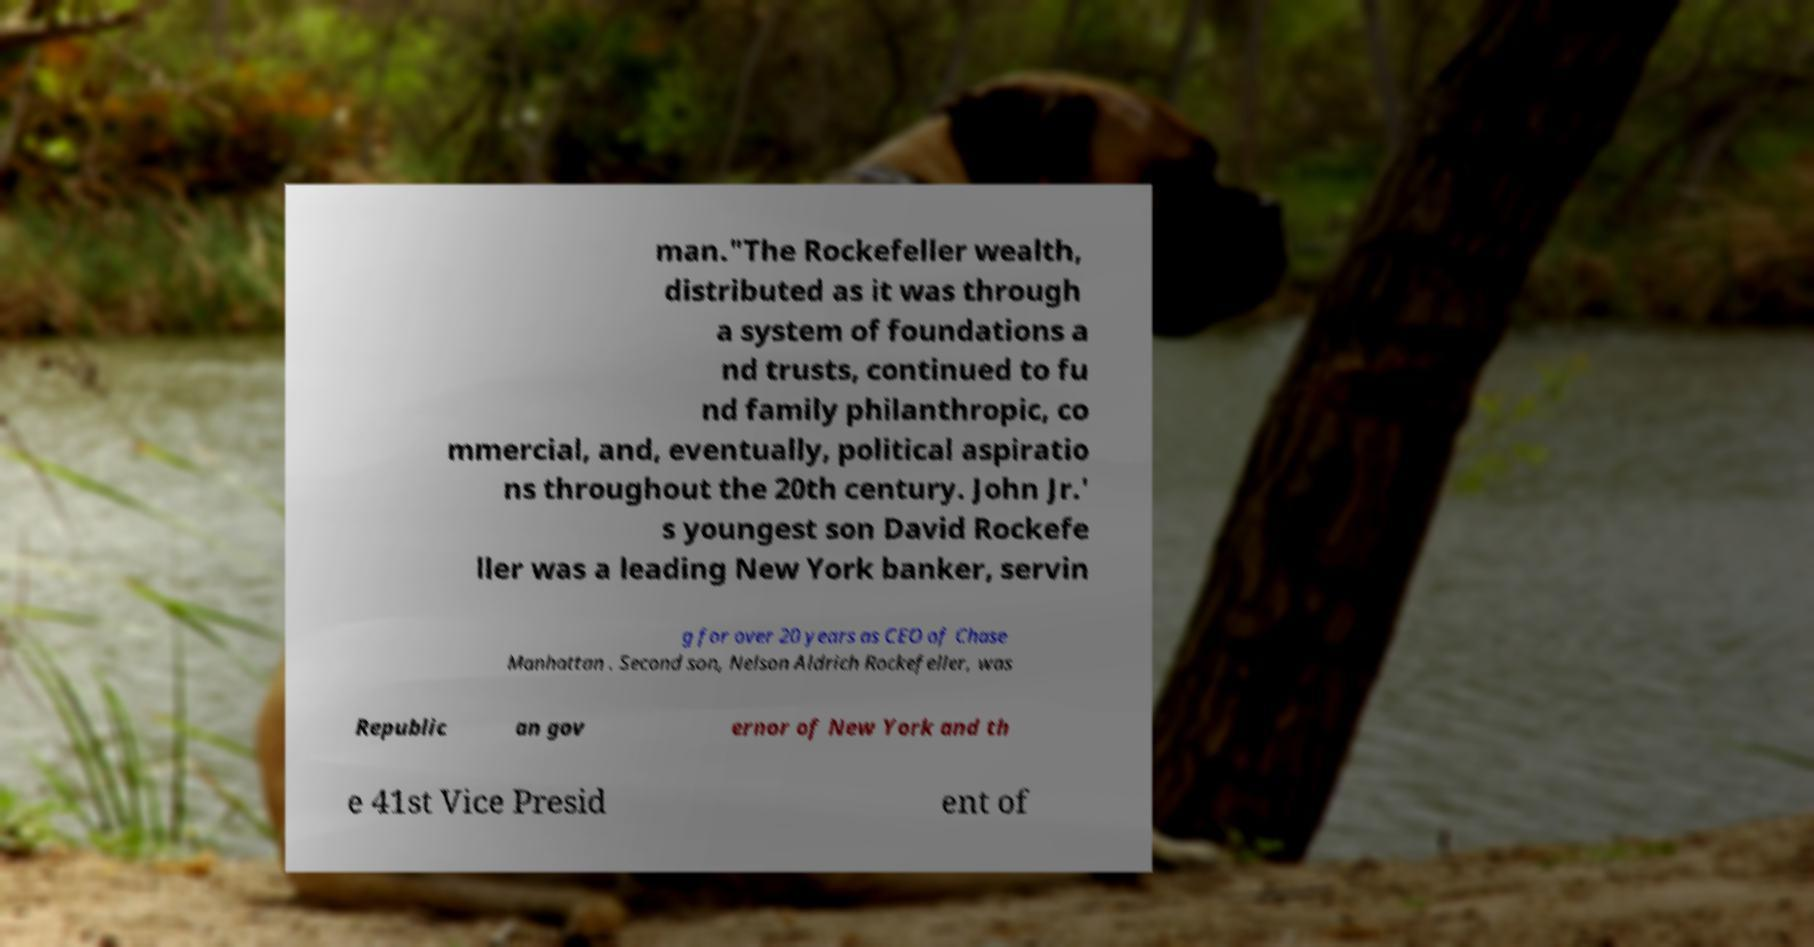For documentation purposes, I need the text within this image transcribed. Could you provide that? man."The Rockefeller wealth, distributed as it was through a system of foundations a nd trusts, continued to fu nd family philanthropic, co mmercial, and, eventually, political aspiratio ns throughout the 20th century. John Jr.' s youngest son David Rockefe ller was a leading New York banker, servin g for over 20 years as CEO of Chase Manhattan . Second son, Nelson Aldrich Rockefeller, was Republic an gov ernor of New York and th e 41st Vice Presid ent of 